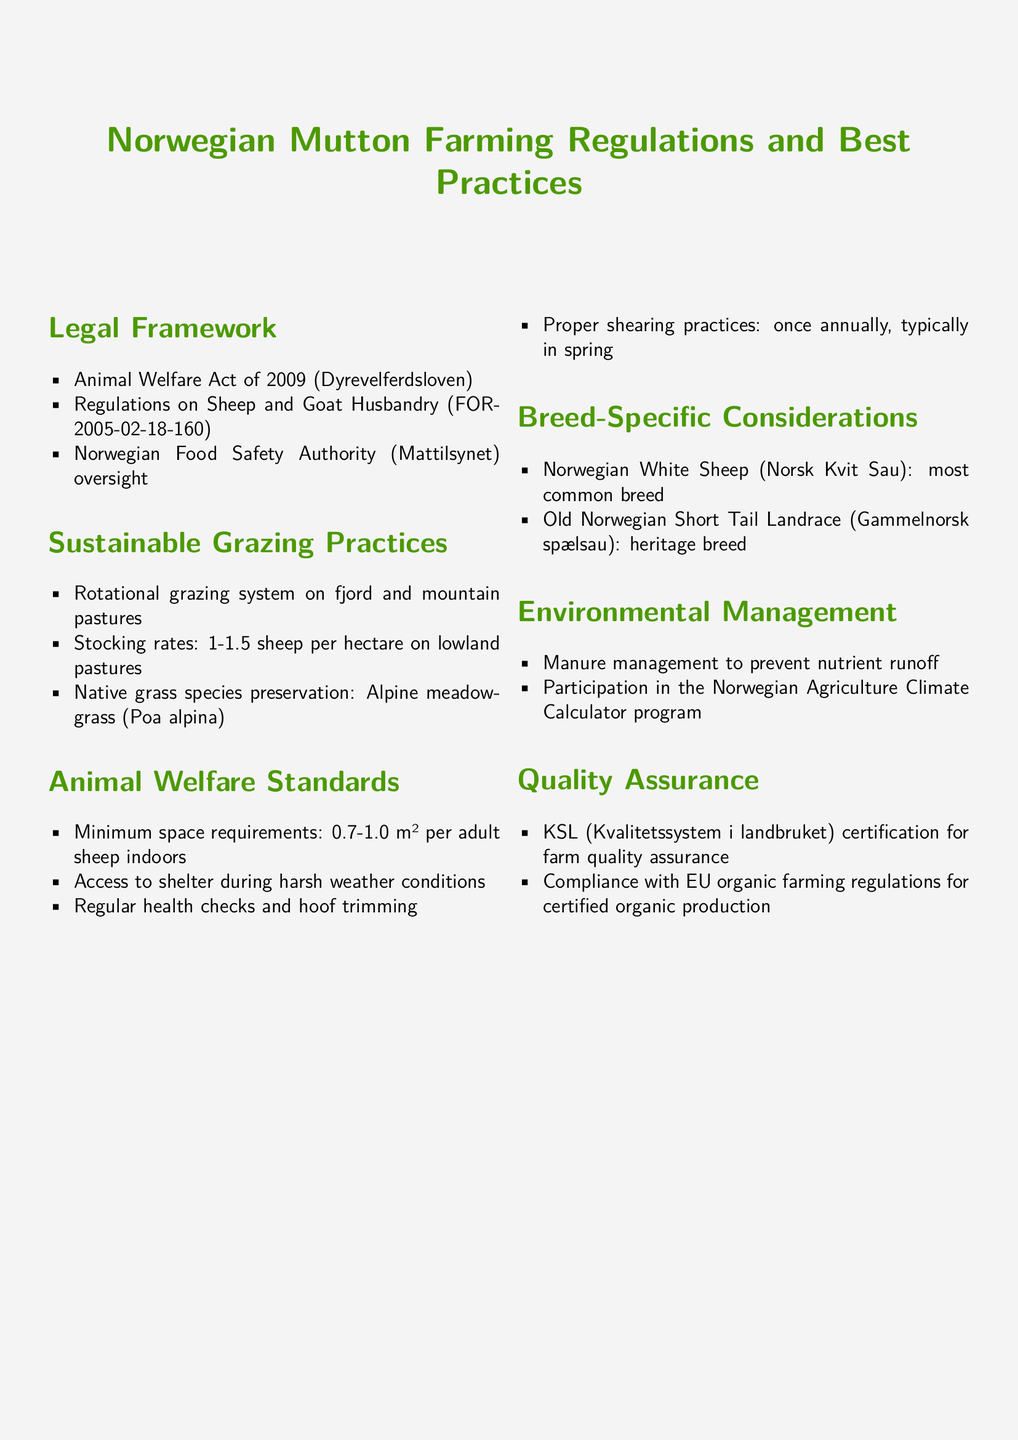What is the main law governing animal welfare in Norway? The Animal Welfare Act of 2009 (Dyrevelferdsloven) is the primary legislation covering animal welfare standards in Norway.
Answer: Animal Welfare Act of 2009 What is the recommended stocking rate for sheep on lowland pastures? The document specifies a stocking rate of 1-1.5 sheep per hectare for lowland pastures.
Answer: 1-1.5 sheep per hectare What is the minimum space requirement per adult sheep indoors? According to the animal welfare standards outlined, the minimum space requirement ranges from 0.7 to 1.0 m² per adult sheep indoors.
Answer: 0.7-1.0 m² Name a heritage breed mentioned in the document. The Old Norwegian Short Tail Landrace (Gammelnorsk spælsau) is noted as a heritage breed in the document.
Answer: Old Norwegian Short Tail Landrace What is the goal of manure management mentioned in the policy? The document states that manure management aims to prevent nutrient runoff.
Answer: Prevent nutrient runoff What type of certification is mentioned for farm quality assurance? KSL (Kvalitetssystem i landbruket) certification is indicated for ensuring farm quality.
Answer: KSL certification Which grazing system is recommended for sustainable practices? The document promotes a rotational grazing system on fjord and mountain pastures as a best practice.
Answer: Rotational grazing system In what season is shearing typically performed? The document specifies that shearing is done once annually, typically in spring.
Answer: Spring 